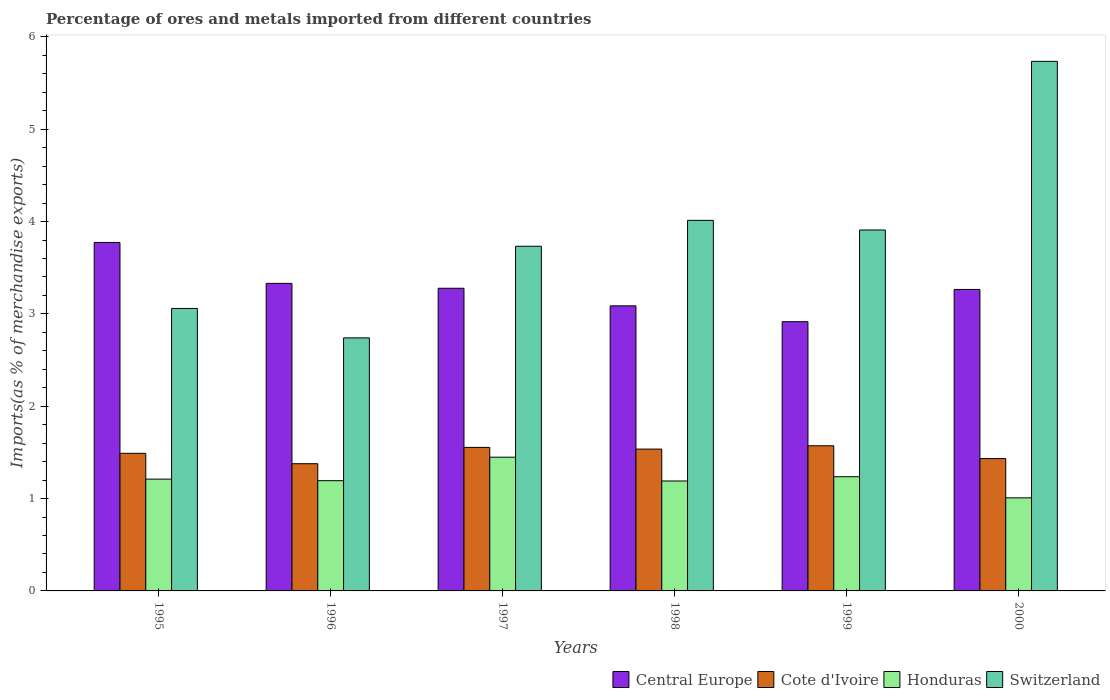How many different coloured bars are there?
Offer a terse response. 4. Are the number of bars on each tick of the X-axis equal?
Offer a very short reply. Yes. How many bars are there on the 2nd tick from the left?
Your answer should be compact. 4. What is the percentage of imports to different countries in Central Europe in 2000?
Your answer should be very brief. 3.27. Across all years, what is the maximum percentage of imports to different countries in Honduras?
Ensure brevity in your answer.  1.45. Across all years, what is the minimum percentage of imports to different countries in Central Europe?
Offer a very short reply. 2.92. In which year was the percentage of imports to different countries in Switzerland maximum?
Your response must be concise. 2000. In which year was the percentage of imports to different countries in Switzerland minimum?
Ensure brevity in your answer.  1996. What is the total percentage of imports to different countries in Cote d'Ivoire in the graph?
Offer a very short reply. 8.96. What is the difference between the percentage of imports to different countries in Cote d'Ivoire in 1996 and that in 2000?
Your answer should be very brief. -0.06. What is the difference between the percentage of imports to different countries in Switzerland in 1999 and the percentage of imports to different countries in Cote d'Ivoire in 1995?
Your response must be concise. 2.42. What is the average percentage of imports to different countries in Switzerland per year?
Offer a terse response. 3.87. In the year 1997, what is the difference between the percentage of imports to different countries in Cote d'Ivoire and percentage of imports to different countries in Central Europe?
Keep it short and to the point. -1.72. In how many years, is the percentage of imports to different countries in Honduras greater than 3.8 %?
Your response must be concise. 0. What is the ratio of the percentage of imports to different countries in Honduras in 1996 to that in 2000?
Your response must be concise. 1.18. Is the percentage of imports to different countries in Honduras in 1997 less than that in 1999?
Ensure brevity in your answer.  No. What is the difference between the highest and the second highest percentage of imports to different countries in Central Europe?
Provide a succinct answer. 0.44. What is the difference between the highest and the lowest percentage of imports to different countries in Honduras?
Your response must be concise. 0.44. In how many years, is the percentage of imports to different countries in Honduras greater than the average percentage of imports to different countries in Honduras taken over all years?
Give a very brief answer. 2. Is the sum of the percentage of imports to different countries in Switzerland in 1996 and 1997 greater than the maximum percentage of imports to different countries in Central Europe across all years?
Offer a very short reply. Yes. What does the 3rd bar from the left in 2000 represents?
Your answer should be compact. Honduras. What does the 3rd bar from the right in 1995 represents?
Your answer should be very brief. Cote d'Ivoire. How many bars are there?
Your answer should be compact. 24. How many years are there in the graph?
Ensure brevity in your answer.  6. Does the graph contain any zero values?
Your answer should be very brief. No. Where does the legend appear in the graph?
Provide a short and direct response. Bottom right. How are the legend labels stacked?
Offer a terse response. Horizontal. What is the title of the graph?
Provide a succinct answer. Percentage of ores and metals imported from different countries. What is the label or title of the X-axis?
Offer a very short reply. Years. What is the label or title of the Y-axis?
Your answer should be compact. Imports(as % of merchandise exports). What is the Imports(as % of merchandise exports) in Central Europe in 1995?
Your response must be concise. 3.77. What is the Imports(as % of merchandise exports) of Cote d'Ivoire in 1995?
Offer a terse response. 1.49. What is the Imports(as % of merchandise exports) in Honduras in 1995?
Your response must be concise. 1.21. What is the Imports(as % of merchandise exports) of Switzerland in 1995?
Your answer should be compact. 3.06. What is the Imports(as % of merchandise exports) of Central Europe in 1996?
Your answer should be compact. 3.33. What is the Imports(as % of merchandise exports) of Cote d'Ivoire in 1996?
Keep it short and to the point. 1.38. What is the Imports(as % of merchandise exports) in Honduras in 1996?
Give a very brief answer. 1.19. What is the Imports(as % of merchandise exports) of Switzerland in 1996?
Give a very brief answer. 2.74. What is the Imports(as % of merchandise exports) of Central Europe in 1997?
Offer a terse response. 3.28. What is the Imports(as % of merchandise exports) in Cote d'Ivoire in 1997?
Provide a succinct answer. 1.55. What is the Imports(as % of merchandise exports) in Honduras in 1997?
Your answer should be very brief. 1.45. What is the Imports(as % of merchandise exports) of Switzerland in 1997?
Your answer should be very brief. 3.73. What is the Imports(as % of merchandise exports) in Central Europe in 1998?
Your answer should be compact. 3.09. What is the Imports(as % of merchandise exports) in Cote d'Ivoire in 1998?
Your answer should be very brief. 1.54. What is the Imports(as % of merchandise exports) in Honduras in 1998?
Make the answer very short. 1.19. What is the Imports(as % of merchandise exports) of Switzerland in 1998?
Ensure brevity in your answer.  4.01. What is the Imports(as % of merchandise exports) of Central Europe in 1999?
Offer a terse response. 2.92. What is the Imports(as % of merchandise exports) of Cote d'Ivoire in 1999?
Keep it short and to the point. 1.57. What is the Imports(as % of merchandise exports) in Honduras in 1999?
Ensure brevity in your answer.  1.24. What is the Imports(as % of merchandise exports) of Switzerland in 1999?
Keep it short and to the point. 3.91. What is the Imports(as % of merchandise exports) in Central Europe in 2000?
Give a very brief answer. 3.27. What is the Imports(as % of merchandise exports) in Cote d'Ivoire in 2000?
Make the answer very short. 1.43. What is the Imports(as % of merchandise exports) of Honduras in 2000?
Provide a succinct answer. 1.01. What is the Imports(as % of merchandise exports) in Switzerland in 2000?
Keep it short and to the point. 5.74. Across all years, what is the maximum Imports(as % of merchandise exports) in Central Europe?
Your answer should be very brief. 3.77. Across all years, what is the maximum Imports(as % of merchandise exports) of Cote d'Ivoire?
Make the answer very short. 1.57. Across all years, what is the maximum Imports(as % of merchandise exports) in Honduras?
Offer a very short reply. 1.45. Across all years, what is the maximum Imports(as % of merchandise exports) in Switzerland?
Give a very brief answer. 5.74. Across all years, what is the minimum Imports(as % of merchandise exports) of Central Europe?
Provide a succinct answer. 2.92. Across all years, what is the minimum Imports(as % of merchandise exports) in Cote d'Ivoire?
Offer a terse response. 1.38. Across all years, what is the minimum Imports(as % of merchandise exports) of Honduras?
Make the answer very short. 1.01. Across all years, what is the minimum Imports(as % of merchandise exports) of Switzerland?
Provide a short and direct response. 2.74. What is the total Imports(as % of merchandise exports) in Central Europe in the graph?
Provide a succinct answer. 19.65. What is the total Imports(as % of merchandise exports) in Cote d'Ivoire in the graph?
Offer a terse response. 8.96. What is the total Imports(as % of merchandise exports) in Honduras in the graph?
Offer a very short reply. 7.29. What is the total Imports(as % of merchandise exports) of Switzerland in the graph?
Make the answer very short. 23.19. What is the difference between the Imports(as % of merchandise exports) of Central Europe in 1995 and that in 1996?
Provide a short and direct response. 0.44. What is the difference between the Imports(as % of merchandise exports) in Cote d'Ivoire in 1995 and that in 1996?
Offer a terse response. 0.11. What is the difference between the Imports(as % of merchandise exports) of Honduras in 1995 and that in 1996?
Provide a succinct answer. 0.02. What is the difference between the Imports(as % of merchandise exports) in Switzerland in 1995 and that in 1996?
Offer a very short reply. 0.32. What is the difference between the Imports(as % of merchandise exports) in Central Europe in 1995 and that in 1997?
Your response must be concise. 0.5. What is the difference between the Imports(as % of merchandise exports) of Cote d'Ivoire in 1995 and that in 1997?
Your response must be concise. -0.06. What is the difference between the Imports(as % of merchandise exports) in Honduras in 1995 and that in 1997?
Offer a very short reply. -0.24. What is the difference between the Imports(as % of merchandise exports) in Switzerland in 1995 and that in 1997?
Offer a terse response. -0.67. What is the difference between the Imports(as % of merchandise exports) of Central Europe in 1995 and that in 1998?
Your response must be concise. 0.69. What is the difference between the Imports(as % of merchandise exports) of Cote d'Ivoire in 1995 and that in 1998?
Your answer should be compact. -0.05. What is the difference between the Imports(as % of merchandise exports) of Honduras in 1995 and that in 1998?
Offer a terse response. 0.02. What is the difference between the Imports(as % of merchandise exports) of Switzerland in 1995 and that in 1998?
Ensure brevity in your answer.  -0.95. What is the difference between the Imports(as % of merchandise exports) in Central Europe in 1995 and that in 1999?
Provide a short and direct response. 0.86. What is the difference between the Imports(as % of merchandise exports) of Cote d'Ivoire in 1995 and that in 1999?
Your answer should be very brief. -0.08. What is the difference between the Imports(as % of merchandise exports) in Honduras in 1995 and that in 1999?
Offer a terse response. -0.03. What is the difference between the Imports(as % of merchandise exports) in Switzerland in 1995 and that in 1999?
Make the answer very short. -0.85. What is the difference between the Imports(as % of merchandise exports) of Central Europe in 1995 and that in 2000?
Ensure brevity in your answer.  0.51. What is the difference between the Imports(as % of merchandise exports) in Cote d'Ivoire in 1995 and that in 2000?
Offer a terse response. 0.06. What is the difference between the Imports(as % of merchandise exports) in Honduras in 1995 and that in 2000?
Keep it short and to the point. 0.2. What is the difference between the Imports(as % of merchandise exports) in Switzerland in 1995 and that in 2000?
Offer a terse response. -2.68. What is the difference between the Imports(as % of merchandise exports) of Central Europe in 1996 and that in 1997?
Provide a succinct answer. 0.05. What is the difference between the Imports(as % of merchandise exports) in Cote d'Ivoire in 1996 and that in 1997?
Make the answer very short. -0.18. What is the difference between the Imports(as % of merchandise exports) of Honduras in 1996 and that in 1997?
Your answer should be very brief. -0.25. What is the difference between the Imports(as % of merchandise exports) in Switzerland in 1996 and that in 1997?
Offer a very short reply. -0.99. What is the difference between the Imports(as % of merchandise exports) of Central Europe in 1996 and that in 1998?
Provide a short and direct response. 0.24. What is the difference between the Imports(as % of merchandise exports) of Cote d'Ivoire in 1996 and that in 1998?
Make the answer very short. -0.16. What is the difference between the Imports(as % of merchandise exports) in Honduras in 1996 and that in 1998?
Offer a very short reply. 0. What is the difference between the Imports(as % of merchandise exports) of Switzerland in 1996 and that in 1998?
Ensure brevity in your answer.  -1.27. What is the difference between the Imports(as % of merchandise exports) of Central Europe in 1996 and that in 1999?
Offer a terse response. 0.41. What is the difference between the Imports(as % of merchandise exports) in Cote d'Ivoire in 1996 and that in 1999?
Provide a short and direct response. -0.19. What is the difference between the Imports(as % of merchandise exports) in Honduras in 1996 and that in 1999?
Offer a very short reply. -0.04. What is the difference between the Imports(as % of merchandise exports) in Switzerland in 1996 and that in 1999?
Keep it short and to the point. -1.17. What is the difference between the Imports(as % of merchandise exports) in Central Europe in 1996 and that in 2000?
Ensure brevity in your answer.  0.07. What is the difference between the Imports(as % of merchandise exports) in Cote d'Ivoire in 1996 and that in 2000?
Your response must be concise. -0.06. What is the difference between the Imports(as % of merchandise exports) in Honduras in 1996 and that in 2000?
Provide a short and direct response. 0.19. What is the difference between the Imports(as % of merchandise exports) of Switzerland in 1996 and that in 2000?
Provide a succinct answer. -2.99. What is the difference between the Imports(as % of merchandise exports) of Central Europe in 1997 and that in 1998?
Provide a succinct answer. 0.19. What is the difference between the Imports(as % of merchandise exports) in Cote d'Ivoire in 1997 and that in 1998?
Your answer should be compact. 0.02. What is the difference between the Imports(as % of merchandise exports) of Honduras in 1997 and that in 1998?
Your answer should be very brief. 0.26. What is the difference between the Imports(as % of merchandise exports) in Switzerland in 1997 and that in 1998?
Ensure brevity in your answer.  -0.28. What is the difference between the Imports(as % of merchandise exports) in Central Europe in 1997 and that in 1999?
Your answer should be compact. 0.36. What is the difference between the Imports(as % of merchandise exports) in Cote d'Ivoire in 1997 and that in 1999?
Give a very brief answer. -0.02. What is the difference between the Imports(as % of merchandise exports) in Honduras in 1997 and that in 1999?
Give a very brief answer. 0.21. What is the difference between the Imports(as % of merchandise exports) of Switzerland in 1997 and that in 1999?
Offer a very short reply. -0.18. What is the difference between the Imports(as % of merchandise exports) of Central Europe in 1997 and that in 2000?
Keep it short and to the point. 0.01. What is the difference between the Imports(as % of merchandise exports) of Cote d'Ivoire in 1997 and that in 2000?
Ensure brevity in your answer.  0.12. What is the difference between the Imports(as % of merchandise exports) in Honduras in 1997 and that in 2000?
Keep it short and to the point. 0.44. What is the difference between the Imports(as % of merchandise exports) of Switzerland in 1997 and that in 2000?
Offer a terse response. -2. What is the difference between the Imports(as % of merchandise exports) of Central Europe in 1998 and that in 1999?
Keep it short and to the point. 0.17. What is the difference between the Imports(as % of merchandise exports) of Cote d'Ivoire in 1998 and that in 1999?
Your response must be concise. -0.04. What is the difference between the Imports(as % of merchandise exports) of Honduras in 1998 and that in 1999?
Offer a terse response. -0.05. What is the difference between the Imports(as % of merchandise exports) in Switzerland in 1998 and that in 1999?
Ensure brevity in your answer.  0.1. What is the difference between the Imports(as % of merchandise exports) in Central Europe in 1998 and that in 2000?
Offer a terse response. -0.18. What is the difference between the Imports(as % of merchandise exports) of Cote d'Ivoire in 1998 and that in 2000?
Keep it short and to the point. 0.1. What is the difference between the Imports(as % of merchandise exports) of Honduras in 1998 and that in 2000?
Your response must be concise. 0.18. What is the difference between the Imports(as % of merchandise exports) of Switzerland in 1998 and that in 2000?
Ensure brevity in your answer.  -1.72. What is the difference between the Imports(as % of merchandise exports) of Central Europe in 1999 and that in 2000?
Offer a very short reply. -0.35. What is the difference between the Imports(as % of merchandise exports) of Cote d'Ivoire in 1999 and that in 2000?
Provide a short and direct response. 0.14. What is the difference between the Imports(as % of merchandise exports) in Honduras in 1999 and that in 2000?
Provide a short and direct response. 0.23. What is the difference between the Imports(as % of merchandise exports) of Switzerland in 1999 and that in 2000?
Provide a succinct answer. -1.83. What is the difference between the Imports(as % of merchandise exports) of Central Europe in 1995 and the Imports(as % of merchandise exports) of Cote d'Ivoire in 1996?
Provide a succinct answer. 2.4. What is the difference between the Imports(as % of merchandise exports) of Central Europe in 1995 and the Imports(as % of merchandise exports) of Honduras in 1996?
Your answer should be compact. 2.58. What is the difference between the Imports(as % of merchandise exports) of Central Europe in 1995 and the Imports(as % of merchandise exports) of Switzerland in 1996?
Provide a short and direct response. 1.03. What is the difference between the Imports(as % of merchandise exports) of Cote d'Ivoire in 1995 and the Imports(as % of merchandise exports) of Honduras in 1996?
Provide a short and direct response. 0.3. What is the difference between the Imports(as % of merchandise exports) in Cote d'Ivoire in 1995 and the Imports(as % of merchandise exports) in Switzerland in 1996?
Your answer should be very brief. -1.25. What is the difference between the Imports(as % of merchandise exports) in Honduras in 1995 and the Imports(as % of merchandise exports) in Switzerland in 1996?
Give a very brief answer. -1.53. What is the difference between the Imports(as % of merchandise exports) of Central Europe in 1995 and the Imports(as % of merchandise exports) of Cote d'Ivoire in 1997?
Keep it short and to the point. 2.22. What is the difference between the Imports(as % of merchandise exports) in Central Europe in 1995 and the Imports(as % of merchandise exports) in Honduras in 1997?
Ensure brevity in your answer.  2.33. What is the difference between the Imports(as % of merchandise exports) of Central Europe in 1995 and the Imports(as % of merchandise exports) of Switzerland in 1997?
Your answer should be compact. 0.04. What is the difference between the Imports(as % of merchandise exports) in Cote d'Ivoire in 1995 and the Imports(as % of merchandise exports) in Honduras in 1997?
Ensure brevity in your answer.  0.04. What is the difference between the Imports(as % of merchandise exports) of Cote d'Ivoire in 1995 and the Imports(as % of merchandise exports) of Switzerland in 1997?
Make the answer very short. -2.24. What is the difference between the Imports(as % of merchandise exports) of Honduras in 1995 and the Imports(as % of merchandise exports) of Switzerland in 1997?
Provide a short and direct response. -2.52. What is the difference between the Imports(as % of merchandise exports) in Central Europe in 1995 and the Imports(as % of merchandise exports) in Cote d'Ivoire in 1998?
Provide a short and direct response. 2.24. What is the difference between the Imports(as % of merchandise exports) of Central Europe in 1995 and the Imports(as % of merchandise exports) of Honduras in 1998?
Your answer should be compact. 2.58. What is the difference between the Imports(as % of merchandise exports) of Central Europe in 1995 and the Imports(as % of merchandise exports) of Switzerland in 1998?
Provide a succinct answer. -0.24. What is the difference between the Imports(as % of merchandise exports) in Cote d'Ivoire in 1995 and the Imports(as % of merchandise exports) in Honduras in 1998?
Your answer should be very brief. 0.3. What is the difference between the Imports(as % of merchandise exports) in Cote d'Ivoire in 1995 and the Imports(as % of merchandise exports) in Switzerland in 1998?
Make the answer very short. -2.52. What is the difference between the Imports(as % of merchandise exports) in Honduras in 1995 and the Imports(as % of merchandise exports) in Switzerland in 1998?
Offer a terse response. -2.8. What is the difference between the Imports(as % of merchandise exports) of Central Europe in 1995 and the Imports(as % of merchandise exports) of Cote d'Ivoire in 1999?
Offer a very short reply. 2.2. What is the difference between the Imports(as % of merchandise exports) of Central Europe in 1995 and the Imports(as % of merchandise exports) of Honduras in 1999?
Ensure brevity in your answer.  2.54. What is the difference between the Imports(as % of merchandise exports) in Central Europe in 1995 and the Imports(as % of merchandise exports) in Switzerland in 1999?
Make the answer very short. -0.14. What is the difference between the Imports(as % of merchandise exports) in Cote d'Ivoire in 1995 and the Imports(as % of merchandise exports) in Honduras in 1999?
Make the answer very short. 0.25. What is the difference between the Imports(as % of merchandise exports) in Cote d'Ivoire in 1995 and the Imports(as % of merchandise exports) in Switzerland in 1999?
Keep it short and to the point. -2.42. What is the difference between the Imports(as % of merchandise exports) of Honduras in 1995 and the Imports(as % of merchandise exports) of Switzerland in 1999?
Provide a succinct answer. -2.7. What is the difference between the Imports(as % of merchandise exports) in Central Europe in 1995 and the Imports(as % of merchandise exports) in Cote d'Ivoire in 2000?
Offer a very short reply. 2.34. What is the difference between the Imports(as % of merchandise exports) of Central Europe in 1995 and the Imports(as % of merchandise exports) of Honduras in 2000?
Keep it short and to the point. 2.77. What is the difference between the Imports(as % of merchandise exports) in Central Europe in 1995 and the Imports(as % of merchandise exports) in Switzerland in 2000?
Your response must be concise. -1.96. What is the difference between the Imports(as % of merchandise exports) of Cote d'Ivoire in 1995 and the Imports(as % of merchandise exports) of Honduras in 2000?
Offer a very short reply. 0.48. What is the difference between the Imports(as % of merchandise exports) of Cote d'Ivoire in 1995 and the Imports(as % of merchandise exports) of Switzerland in 2000?
Provide a short and direct response. -4.25. What is the difference between the Imports(as % of merchandise exports) in Honduras in 1995 and the Imports(as % of merchandise exports) in Switzerland in 2000?
Provide a short and direct response. -4.52. What is the difference between the Imports(as % of merchandise exports) of Central Europe in 1996 and the Imports(as % of merchandise exports) of Cote d'Ivoire in 1997?
Your answer should be very brief. 1.78. What is the difference between the Imports(as % of merchandise exports) of Central Europe in 1996 and the Imports(as % of merchandise exports) of Honduras in 1997?
Make the answer very short. 1.88. What is the difference between the Imports(as % of merchandise exports) in Central Europe in 1996 and the Imports(as % of merchandise exports) in Switzerland in 1997?
Provide a short and direct response. -0.4. What is the difference between the Imports(as % of merchandise exports) of Cote d'Ivoire in 1996 and the Imports(as % of merchandise exports) of Honduras in 1997?
Provide a succinct answer. -0.07. What is the difference between the Imports(as % of merchandise exports) in Cote d'Ivoire in 1996 and the Imports(as % of merchandise exports) in Switzerland in 1997?
Provide a succinct answer. -2.36. What is the difference between the Imports(as % of merchandise exports) of Honduras in 1996 and the Imports(as % of merchandise exports) of Switzerland in 1997?
Make the answer very short. -2.54. What is the difference between the Imports(as % of merchandise exports) of Central Europe in 1996 and the Imports(as % of merchandise exports) of Cote d'Ivoire in 1998?
Offer a very short reply. 1.79. What is the difference between the Imports(as % of merchandise exports) of Central Europe in 1996 and the Imports(as % of merchandise exports) of Honduras in 1998?
Your answer should be compact. 2.14. What is the difference between the Imports(as % of merchandise exports) in Central Europe in 1996 and the Imports(as % of merchandise exports) in Switzerland in 1998?
Offer a terse response. -0.68. What is the difference between the Imports(as % of merchandise exports) of Cote d'Ivoire in 1996 and the Imports(as % of merchandise exports) of Honduras in 1998?
Offer a terse response. 0.19. What is the difference between the Imports(as % of merchandise exports) in Cote d'Ivoire in 1996 and the Imports(as % of merchandise exports) in Switzerland in 1998?
Your answer should be compact. -2.64. What is the difference between the Imports(as % of merchandise exports) in Honduras in 1996 and the Imports(as % of merchandise exports) in Switzerland in 1998?
Make the answer very short. -2.82. What is the difference between the Imports(as % of merchandise exports) of Central Europe in 1996 and the Imports(as % of merchandise exports) of Cote d'Ivoire in 1999?
Provide a short and direct response. 1.76. What is the difference between the Imports(as % of merchandise exports) in Central Europe in 1996 and the Imports(as % of merchandise exports) in Honduras in 1999?
Provide a succinct answer. 2.09. What is the difference between the Imports(as % of merchandise exports) in Central Europe in 1996 and the Imports(as % of merchandise exports) in Switzerland in 1999?
Offer a terse response. -0.58. What is the difference between the Imports(as % of merchandise exports) of Cote d'Ivoire in 1996 and the Imports(as % of merchandise exports) of Honduras in 1999?
Your answer should be very brief. 0.14. What is the difference between the Imports(as % of merchandise exports) of Cote d'Ivoire in 1996 and the Imports(as % of merchandise exports) of Switzerland in 1999?
Your answer should be very brief. -2.53. What is the difference between the Imports(as % of merchandise exports) of Honduras in 1996 and the Imports(as % of merchandise exports) of Switzerland in 1999?
Provide a short and direct response. -2.72. What is the difference between the Imports(as % of merchandise exports) of Central Europe in 1996 and the Imports(as % of merchandise exports) of Cote d'Ivoire in 2000?
Your answer should be compact. 1.9. What is the difference between the Imports(as % of merchandise exports) of Central Europe in 1996 and the Imports(as % of merchandise exports) of Honduras in 2000?
Give a very brief answer. 2.32. What is the difference between the Imports(as % of merchandise exports) of Central Europe in 1996 and the Imports(as % of merchandise exports) of Switzerland in 2000?
Your answer should be very brief. -2.4. What is the difference between the Imports(as % of merchandise exports) in Cote d'Ivoire in 1996 and the Imports(as % of merchandise exports) in Honduras in 2000?
Offer a very short reply. 0.37. What is the difference between the Imports(as % of merchandise exports) of Cote d'Ivoire in 1996 and the Imports(as % of merchandise exports) of Switzerland in 2000?
Ensure brevity in your answer.  -4.36. What is the difference between the Imports(as % of merchandise exports) in Honduras in 1996 and the Imports(as % of merchandise exports) in Switzerland in 2000?
Provide a short and direct response. -4.54. What is the difference between the Imports(as % of merchandise exports) of Central Europe in 1997 and the Imports(as % of merchandise exports) of Cote d'Ivoire in 1998?
Your answer should be compact. 1.74. What is the difference between the Imports(as % of merchandise exports) of Central Europe in 1997 and the Imports(as % of merchandise exports) of Honduras in 1998?
Offer a very short reply. 2.09. What is the difference between the Imports(as % of merchandise exports) of Central Europe in 1997 and the Imports(as % of merchandise exports) of Switzerland in 1998?
Give a very brief answer. -0.74. What is the difference between the Imports(as % of merchandise exports) in Cote d'Ivoire in 1997 and the Imports(as % of merchandise exports) in Honduras in 1998?
Provide a succinct answer. 0.36. What is the difference between the Imports(as % of merchandise exports) in Cote d'Ivoire in 1997 and the Imports(as % of merchandise exports) in Switzerland in 1998?
Provide a short and direct response. -2.46. What is the difference between the Imports(as % of merchandise exports) of Honduras in 1997 and the Imports(as % of merchandise exports) of Switzerland in 1998?
Provide a short and direct response. -2.57. What is the difference between the Imports(as % of merchandise exports) of Central Europe in 1997 and the Imports(as % of merchandise exports) of Cote d'Ivoire in 1999?
Provide a succinct answer. 1.71. What is the difference between the Imports(as % of merchandise exports) in Central Europe in 1997 and the Imports(as % of merchandise exports) in Honduras in 1999?
Offer a terse response. 2.04. What is the difference between the Imports(as % of merchandise exports) of Central Europe in 1997 and the Imports(as % of merchandise exports) of Switzerland in 1999?
Provide a short and direct response. -0.63. What is the difference between the Imports(as % of merchandise exports) in Cote d'Ivoire in 1997 and the Imports(as % of merchandise exports) in Honduras in 1999?
Give a very brief answer. 0.32. What is the difference between the Imports(as % of merchandise exports) in Cote d'Ivoire in 1997 and the Imports(as % of merchandise exports) in Switzerland in 1999?
Keep it short and to the point. -2.35. What is the difference between the Imports(as % of merchandise exports) of Honduras in 1997 and the Imports(as % of merchandise exports) of Switzerland in 1999?
Offer a very short reply. -2.46. What is the difference between the Imports(as % of merchandise exports) in Central Europe in 1997 and the Imports(as % of merchandise exports) in Cote d'Ivoire in 2000?
Offer a very short reply. 1.84. What is the difference between the Imports(as % of merchandise exports) in Central Europe in 1997 and the Imports(as % of merchandise exports) in Honduras in 2000?
Offer a terse response. 2.27. What is the difference between the Imports(as % of merchandise exports) of Central Europe in 1997 and the Imports(as % of merchandise exports) of Switzerland in 2000?
Provide a short and direct response. -2.46. What is the difference between the Imports(as % of merchandise exports) of Cote d'Ivoire in 1997 and the Imports(as % of merchandise exports) of Honduras in 2000?
Your answer should be compact. 0.55. What is the difference between the Imports(as % of merchandise exports) in Cote d'Ivoire in 1997 and the Imports(as % of merchandise exports) in Switzerland in 2000?
Give a very brief answer. -4.18. What is the difference between the Imports(as % of merchandise exports) in Honduras in 1997 and the Imports(as % of merchandise exports) in Switzerland in 2000?
Your answer should be very brief. -4.29. What is the difference between the Imports(as % of merchandise exports) of Central Europe in 1998 and the Imports(as % of merchandise exports) of Cote d'Ivoire in 1999?
Your answer should be compact. 1.52. What is the difference between the Imports(as % of merchandise exports) in Central Europe in 1998 and the Imports(as % of merchandise exports) in Honduras in 1999?
Your answer should be very brief. 1.85. What is the difference between the Imports(as % of merchandise exports) in Central Europe in 1998 and the Imports(as % of merchandise exports) in Switzerland in 1999?
Offer a terse response. -0.82. What is the difference between the Imports(as % of merchandise exports) in Cote d'Ivoire in 1998 and the Imports(as % of merchandise exports) in Honduras in 1999?
Your answer should be compact. 0.3. What is the difference between the Imports(as % of merchandise exports) in Cote d'Ivoire in 1998 and the Imports(as % of merchandise exports) in Switzerland in 1999?
Ensure brevity in your answer.  -2.37. What is the difference between the Imports(as % of merchandise exports) in Honduras in 1998 and the Imports(as % of merchandise exports) in Switzerland in 1999?
Ensure brevity in your answer.  -2.72. What is the difference between the Imports(as % of merchandise exports) of Central Europe in 1998 and the Imports(as % of merchandise exports) of Cote d'Ivoire in 2000?
Offer a terse response. 1.65. What is the difference between the Imports(as % of merchandise exports) of Central Europe in 1998 and the Imports(as % of merchandise exports) of Honduras in 2000?
Provide a short and direct response. 2.08. What is the difference between the Imports(as % of merchandise exports) in Central Europe in 1998 and the Imports(as % of merchandise exports) in Switzerland in 2000?
Ensure brevity in your answer.  -2.65. What is the difference between the Imports(as % of merchandise exports) of Cote d'Ivoire in 1998 and the Imports(as % of merchandise exports) of Honduras in 2000?
Keep it short and to the point. 0.53. What is the difference between the Imports(as % of merchandise exports) of Cote d'Ivoire in 1998 and the Imports(as % of merchandise exports) of Switzerland in 2000?
Your answer should be very brief. -4.2. What is the difference between the Imports(as % of merchandise exports) of Honduras in 1998 and the Imports(as % of merchandise exports) of Switzerland in 2000?
Give a very brief answer. -4.54. What is the difference between the Imports(as % of merchandise exports) in Central Europe in 1999 and the Imports(as % of merchandise exports) in Cote d'Ivoire in 2000?
Ensure brevity in your answer.  1.48. What is the difference between the Imports(as % of merchandise exports) in Central Europe in 1999 and the Imports(as % of merchandise exports) in Honduras in 2000?
Your answer should be very brief. 1.91. What is the difference between the Imports(as % of merchandise exports) of Central Europe in 1999 and the Imports(as % of merchandise exports) of Switzerland in 2000?
Your answer should be very brief. -2.82. What is the difference between the Imports(as % of merchandise exports) of Cote d'Ivoire in 1999 and the Imports(as % of merchandise exports) of Honduras in 2000?
Your answer should be compact. 0.56. What is the difference between the Imports(as % of merchandise exports) in Cote d'Ivoire in 1999 and the Imports(as % of merchandise exports) in Switzerland in 2000?
Offer a very short reply. -4.16. What is the difference between the Imports(as % of merchandise exports) in Honduras in 1999 and the Imports(as % of merchandise exports) in Switzerland in 2000?
Your answer should be very brief. -4.5. What is the average Imports(as % of merchandise exports) of Central Europe per year?
Keep it short and to the point. 3.28. What is the average Imports(as % of merchandise exports) of Cote d'Ivoire per year?
Your answer should be very brief. 1.49. What is the average Imports(as % of merchandise exports) in Honduras per year?
Offer a very short reply. 1.21. What is the average Imports(as % of merchandise exports) in Switzerland per year?
Your answer should be compact. 3.87. In the year 1995, what is the difference between the Imports(as % of merchandise exports) of Central Europe and Imports(as % of merchandise exports) of Cote d'Ivoire?
Offer a terse response. 2.28. In the year 1995, what is the difference between the Imports(as % of merchandise exports) of Central Europe and Imports(as % of merchandise exports) of Honduras?
Give a very brief answer. 2.56. In the year 1995, what is the difference between the Imports(as % of merchandise exports) in Central Europe and Imports(as % of merchandise exports) in Switzerland?
Your answer should be very brief. 0.71. In the year 1995, what is the difference between the Imports(as % of merchandise exports) of Cote d'Ivoire and Imports(as % of merchandise exports) of Honduras?
Your answer should be compact. 0.28. In the year 1995, what is the difference between the Imports(as % of merchandise exports) of Cote d'Ivoire and Imports(as % of merchandise exports) of Switzerland?
Provide a short and direct response. -1.57. In the year 1995, what is the difference between the Imports(as % of merchandise exports) of Honduras and Imports(as % of merchandise exports) of Switzerland?
Your answer should be compact. -1.85. In the year 1996, what is the difference between the Imports(as % of merchandise exports) in Central Europe and Imports(as % of merchandise exports) in Cote d'Ivoire?
Your answer should be very brief. 1.95. In the year 1996, what is the difference between the Imports(as % of merchandise exports) of Central Europe and Imports(as % of merchandise exports) of Honduras?
Offer a terse response. 2.14. In the year 1996, what is the difference between the Imports(as % of merchandise exports) in Central Europe and Imports(as % of merchandise exports) in Switzerland?
Your answer should be very brief. 0.59. In the year 1996, what is the difference between the Imports(as % of merchandise exports) in Cote d'Ivoire and Imports(as % of merchandise exports) in Honduras?
Offer a very short reply. 0.18. In the year 1996, what is the difference between the Imports(as % of merchandise exports) of Cote d'Ivoire and Imports(as % of merchandise exports) of Switzerland?
Your answer should be very brief. -1.36. In the year 1996, what is the difference between the Imports(as % of merchandise exports) of Honduras and Imports(as % of merchandise exports) of Switzerland?
Your response must be concise. -1.55. In the year 1997, what is the difference between the Imports(as % of merchandise exports) in Central Europe and Imports(as % of merchandise exports) in Cote d'Ivoire?
Ensure brevity in your answer.  1.72. In the year 1997, what is the difference between the Imports(as % of merchandise exports) in Central Europe and Imports(as % of merchandise exports) in Honduras?
Provide a succinct answer. 1.83. In the year 1997, what is the difference between the Imports(as % of merchandise exports) of Central Europe and Imports(as % of merchandise exports) of Switzerland?
Offer a terse response. -0.45. In the year 1997, what is the difference between the Imports(as % of merchandise exports) in Cote d'Ivoire and Imports(as % of merchandise exports) in Honduras?
Your answer should be compact. 0.11. In the year 1997, what is the difference between the Imports(as % of merchandise exports) in Cote d'Ivoire and Imports(as % of merchandise exports) in Switzerland?
Provide a short and direct response. -2.18. In the year 1997, what is the difference between the Imports(as % of merchandise exports) of Honduras and Imports(as % of merchandise exports) of Switzerland?
Give a very brief answer. -2.28. In the year 1998, what is the difference between the Imports(as % of merchandise exports) of Central Europe and Imports(as % of merchandise exports) of Cote d'Ivoire?
Your response must be concise. 1.55. In the year 1998, what is the difference between the Imports(as % of merchandise exports) of Central Europe and Imports(as % of merchandise exports) of Honduras?
Your answer should be very brief. 1.9. In the year 1998, what is the difference between the Imports(as % of merchandise exports) in Central Europe and Imports(as % of merchandise exports) in Switzerland?
Keep it short and to the point. -0.93. In the year 1998, what is the difference between the Imports(as % of merchandise exports) of Cote d'Ivoire and Imports(as % of merchandise exports) of Honduras?
Offer a terse response. 0.35. In the year 1998, what is the difference between the Imports(as % of merchandise exports) in Cote d'Ivoire and Imports(as % of merchandise exports) in Switzerland?
Provide a succinct answer. -2.48. In the year 1998, what is the difference between the Imports(as % of merchandise exports) in Honduras and Imports(as % of merchandise exports) in Switzerland?
Make the answer very short. -2.82. In the year 1999, what is the difference between the Imports(as % of merchandise exports) in Central Europe and Imports(as % of merchandise exports) in Cote d'Ivoire?
Offer a terse response. 1.34. In the year 1999, what is the difference between the Imports(as % of merchandise exports) of Central Europe and Imports(as % of merchandise exports) of Honduras?
Provide a short and direct response. 1.68. In the year 1999, what is the difference between the Imports(as % of merchandise exports) of Central Europe and Imports(as % of merchandise exports) of Switzerland?
Your answer should be very brief. -0.99. In the year 1999, what is the difference between the Imports(as % of merchandise exports) of Cote d'Ivoire and Imports(as % of merchandise exports) of Honduras?
Provide a succinct answer. 0.34. In the year 1999, what is the difference between the Imports(as % of merchandise exports) in Cote d'Ivoire and Imports(as % of merchandise exports) in Switzerland?
Ensure brevity in your answer.  -2.34. In the year 1999, what is the difference between the Imports(as % of merchandise exports) of Honduras and Imports(as % of merchandise exports) of Switzerland?
Provide a succinct answer. -2.67. In the year 2000, what is the difference between the Imports(as % of merchandise exports) in Central Europe and Imports(as % of merchandise exports) in Cote d'Ivoire?
Offer a very short reply. 1.83. In the year 2000, what is the difference between the Imports(as % of merchandise exports) in Central Europe and Imports(as % of merchandise exports) in Honduras?
Offer a very short reply. 2.26. In the year 2000, what is the difference between the Imports(as % of merchandise exports) of Central Europe and Imports(as % of merchandise exports) of Switzerland?
Make the answer very short. -2.47. In the year 2000, what is the difference between the Imports(as % of merchandise exports) of Cote d'Ivoire and Imports(as % of merchandise exports) of Honduras?
Your answer should be compact. 0.43. In the year 2000, what is the difference between the Imports(as % of merchandise exports) in Cote d'Ivoire and Imports(as % of merchandise exports) in Switzerland?
Your response must be concise. -4.3. In the year 2000, what is the difference between the Imports(as % of merchandise exports) in Honduras and Imports(as % of merchandise exports) in Switzerland?
Your answer should be compact. -4.73. What is the ratio of the Imports(as % of merchandise exports) in Central Europe in 1995 to that in 1996?
Provide a succinct answer. 1.13. What is the ratio of the Imports(as % of merchandise exports) in Cote d'Ivoire in 1995 to that in 1996?
Provide a succinct answer. 1.08. What is the ratio of the Imports(as % of merchandise exports) of Honduras in 1995 to that in 1996?
Offer a very short reply. 1.01. What is the ratio of the Imports(as % of merchandise exports) of Switzerland in 1995 to that in 1996?
Offer a very short reply. 1.12. What is the ratio of the Imports(as % of merchandise exports) in Central Europe in 1995 to that in 1997?
Make the answer very short. 1.15. What is the ratio of the Imports(as % of merchandise exports) of Cote d'Ivoire in 1995 to that in 1997?
Offer a terse response. 0.96. What is the ratio of the Imports(as % of merchandise exports) of Honduras in 1995 to that in 1997?
Offer a terse response. 0.84. What is the ratio of the Imports(as % of merchandise exports) in Switzerland in 1995 to that in 1997?
Offer a very short reply. 0.82. What is the ratio of the Imports(as % of merchandise exports) of Central Europe in 1995 to that in 1998?
Keep it short and to the point. 1.22. What is the ratio of the Imports(as % of merchandise exports) in Cote d'Ivoire in 1995 to that in 1998?
Provide a short and direct response. 0.97. What is the ratio of the Imports(as % of merchandise exports) of Honduras in 1995 to that in 1998?
Offer a terse response. 1.02. What is the ratio of the Imports(as % of merchandise exports) of Switzerland in 1995 to that in 1998?
Offer a terse response. 0.76. What is the ratio of the Imports(as % of merchandise exports) of Central Europe in 1995 to that in 1999?
Offer a very short reply. 1.29. What is the ratio of the Imports(as % of merchandise exports) of Cote d'Ivoire in 1995 to that in 1999?
Your answer should be compact. 0.95. What is the ratio of the Imports(as % of merchandise exports) in Switzerland in 1995 to that in 1999?
Keep it short and to the point. 0.78. What is the ratio of the Imports(as % of merchandise exports) of Central Europe in 1995 to that in 2000?
Offer a terse response. 1.16. What is the ratio of the Imports(as % of merchandise exports) in Cote d'Ivoire in 1995 to that in 2000?
Keep it short and to the point. 1.04. What is the ratio of the Imports(as % of merchandise exports) in Honduras in 1995 to that in 2000?
Provide a short and direct response. 1.2. What is the ratio of the Imports(as % of merchandise exports) of Switzerland in 1995 to that in 2000?
Make the answer very short. 0.53. What is the ratio of the Imports(as % of merchandise exports) of Central Europe in 1996 to that in 1997?
Offer a terse response. 1.02. What is the ratio of the Imports(as % of merchandise exports) in Cote d'Ivoire in 1996 to that in 1997?
Ensure brevity in your answer.  0.89. What is the ratio of the Imports(as % of merchandise exports) in Honduras in 1996 to that in 1997?
Offer a terse response. 0.82. What is the ratio of the Imports(as % of merchandise exports) of Switzerland in 1996 to that in 1997?
Your answer should be very brief. 0.73. What is the ratio of the Imports(as % of merchandise exports) of Central Europe in 1996 to that in 1998?
Keep it short and to the point. 1.08. What is the ratio of the Imports(as % of merchandise exports) in Cote d'Ivoire in 1996 to that in 1998?
Your answer should be compact. 0.9. What is the ratio of the Imports(as % of merchandise exports) of Honduras in 1996 to that in 1998?
Provide a short and direct response. 1. What is the ratio of the Imports(as % of merchandise exports) of Switzerland in 1996 to that in 1998?
Offer a terse response. 0.68. What is the ratio of the Imports(as % of merchandise exports) of Central Europe in 1996 to that in 1999?
Your answer should be compact. 1.14. What is the ratio of the Imports(as % of merchandise exports) in Cote d'Ivoire in 1996 to that in 1999?
Your answer should be very brief. 0.88. What is the ratio of the Imports(as % of merchandise exports) of Honduras in 1996 to that in 1999?
Provide a short and direct response. 0.97. What is the ratio of the Imports(as % of merchandise exports) in Switzerland in 1996 to that in 1999?
Offer a terse response. 0.7. What is the ratio of the Imports(as % of merchandise exports) in Central Europe in 1996 to that in 2000?
Keep it short and to the point. 1.02. What is the ratio of the Imports(as % of merchandise exports) in Cote d'Ivoire in 1996 to that in 2000?
Make the answer very short. 0.96. What is the ratio of the Imports(as % of merchandise exports) of Honduras in 1996 to that in 2000?
Your answer should be very brief. 1.18. What is the ratio of the Imports(as % of merchandise exports) in Switzerland in 1996 to that in 2000?
Ensure brevity in your answer.  0.48. What is the ratio of the Imports(as % of merchandise exports) in Central Europe in 1997 to that in 1998?
Offer a very short reply. 1.06. What is the ratio of the Imports(as % of merchandise exports) of Cote d'Ivoire in 1997 to that in 1998?
Your response must be concise. 1.01. What is the ratio of the Imports(as % of merchandise exports) in Honduras in 1997 to that in 1998?
Offer a very short reply. 1.22. What is the ratio of the Imports(as % of merchandise exports) in Switzerland in 1997 to that in 1998?
Provide a short and direct response. 0.93. What is the ratio of the Imports(as % of merchandise exports) of Central Europe in 1997 to that in 1999?
Ensure brevity in your answer.  1.12. What is the ratio of the Imports(as % of merchandise exports) in Cote d'Ivoire in 1997 to that in 1999?
Ensure brevity in your answer.  0.99. What is the ratio of the Imports(as % of merchandise exports) of Honduras in 1997 to that in 1999?
Make the answer very short. 1.17. What is the ratio of the Imports(as % of merchandise exports) of Switzerland in 1997 to that in 1999?
Your response must be concise. 0.95. What is the ratio of the Imports(as % of merchandise exports) in Cote d'Ivoire in 1997 to that in 2000?
Offer a terse response. 1.08. What is the ratio of the Imports(as % of merchandise exports) of Honduras in 1997 to that in 2000?
Make the answer very short. 1.44. What is the ratio of the Imports(as % of merchandise exports) in Switzerland in 1997 to that in 2000?
Offer a terse response. 0.65. What is the ratio of the Imports(as % of merchandise exports) in Central Europe in 1998 to that in 1999?
Make the answer very short. 1.06. What is the ratio of the Imports(as % of merchandise exports) of Cote d'Ivoire in 1998 to that in 1999?
Ensure brevity in your answer.  0.98. What is the ratio of the Imports(as % of merchandise exports) in Honduras in 1998 to that in 1999?
Offer a very short reply. 0.96. What is the ratio of the Imports(as % of merchandise exports) of Switzerland in 1998 to that in 1999?
Offer a very short reply. 1.03. What is the ratio of the Imports(as % of merchandise exports) of Central Europe in 1998 to that in 2000?
Make the answer very short. 0.95. What is the ratio of the Imports(as % of merchandise exports) in Cote d'Ivoire in 1998 to that in 2000?
Provide a succinct answer. 1.07. What is the ratio of the Imports(as % of merchandise exports) in Honduras in 1998 to that in 2000?
Ensure brevity in your answer.  1.18. What is the ratio of the Imports(as % of merchandise exports) of Switzerland in 1998 to that in 2000?
Offer a terse response. 0.7. What is the ratio of the Imports(as % of merchandise exports) of Central Europe in 1999 to that in 2000?
Ensure brevity in your answer.  0.89. What is the ratio of the Imports(as % of merchandise exports) in Cote d'Ivoire in 1999 to that in 2000?
Your response must be concise. 1.1. What is the ratio of the Imports(as % of merchandise exports) of Honduras in 1999 to that in 2000?
Offer a very short reply. 1.23. What is the ratio of the Imports(as % of merchandise exports) in Switzerland in 1999 to that in 2000?
Your answer should be very brief. 0.68. What is the difference between the highest and the second highest Imports(as % of merchandise exports) of Central Europe?
Keep it short and to the point. 0.44. What is the difference between the highest and the second highest Imports(as % of merchandise exports) in Cote d'Ivoire?
Offer a terse response. 0.02. What is the difference between the highest and the second highest Imports(as % of merchandise exports) of Honduras?
Provide a short and direct response. 0.21. What is the difference between the highest and the second highest Imports(as % of merchandise exports) of Switzerland?
Keep it short and to the point. 1.72. What is the difference between the highest and the lowest Imports(as % of merchandise exports) in Central Europe?
Provide a succinct answer. 0.86. What is the difference between the highest and the lowest Imports(as % of merchandise exports) in Cote d'Ivoire?
Your response must be concise. 0.19. What is the difference between the highest and the lowest Imports(as % of merchandise exports) in Honduras?
Ensure brevity in your answer.  0.44. What is the difference between the highest and the lowest Imports(as % of merchandise exports) in Switzerland?
Your answer should be very brief. 2.99. 